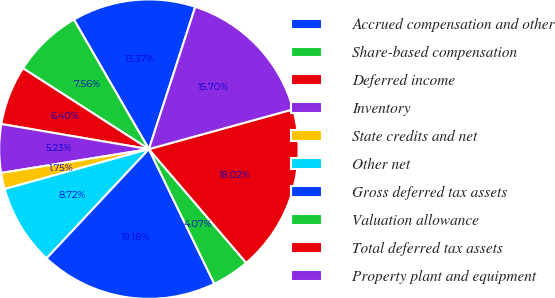<chart> <loc_0><loc_0><loc_500><loc_500><pie_chart><fcel>Accrued compensation and other<fcel>Share-based compensation<fcel>Deferred income<fcel>Inventory<fcel>State credits and net<fcel>Other net<fcel>Gross deferred tax assets<fcel>Valuation allowance<fcel>Total deferred tax assets<fcel>Property plant and equipment<nl><fcel>13.37%<fcel>7.56%<fcel>6.4%<fcel>5.23%<fcel>1.75%<fcel>8.72%<fcel>19.18%<fcel>4.07%<fcel>18.02%<fcel>15.7%<nl></chart> 